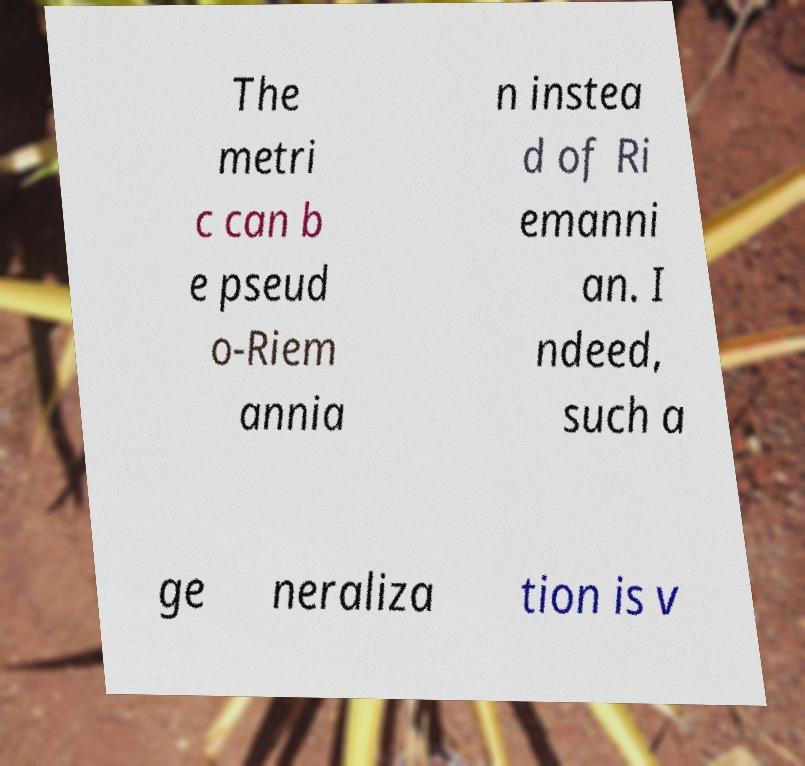I need the written content from this picture converted into text. Can you do that? The metri c can b e pseud o-Riem annia n instea d of Ri emanni an. I ndeed, such a ge neraliza tion is v 